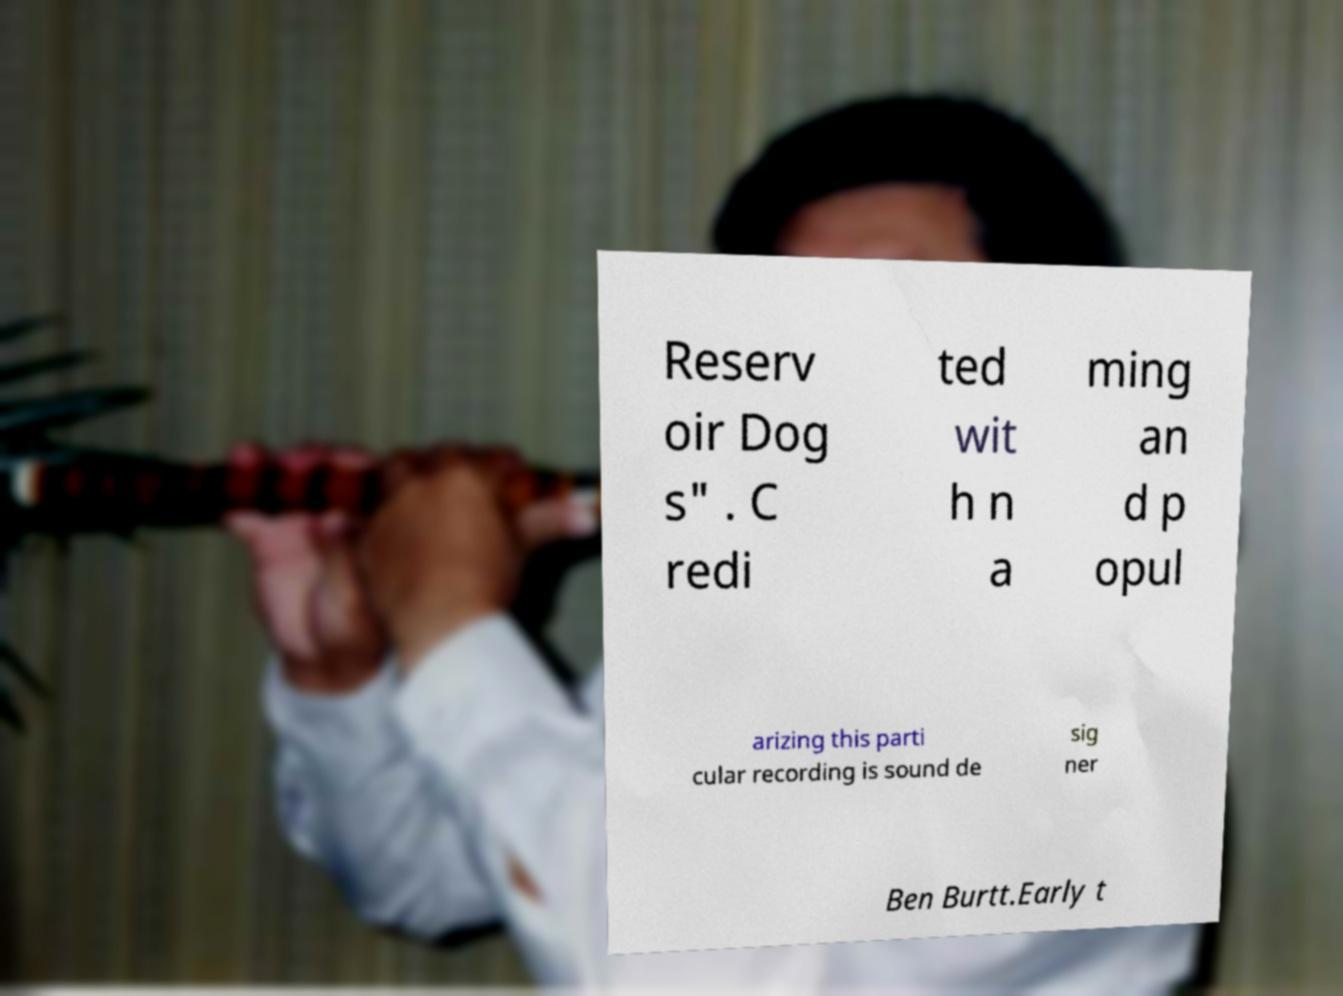I need the written content from this picture converted into text. Can you do that? Reserv oir Dog s" . C redi ted wit h n a ming an d p opul arizing this parti cular recording is sound de sig ner Ben Burtt.Early t 